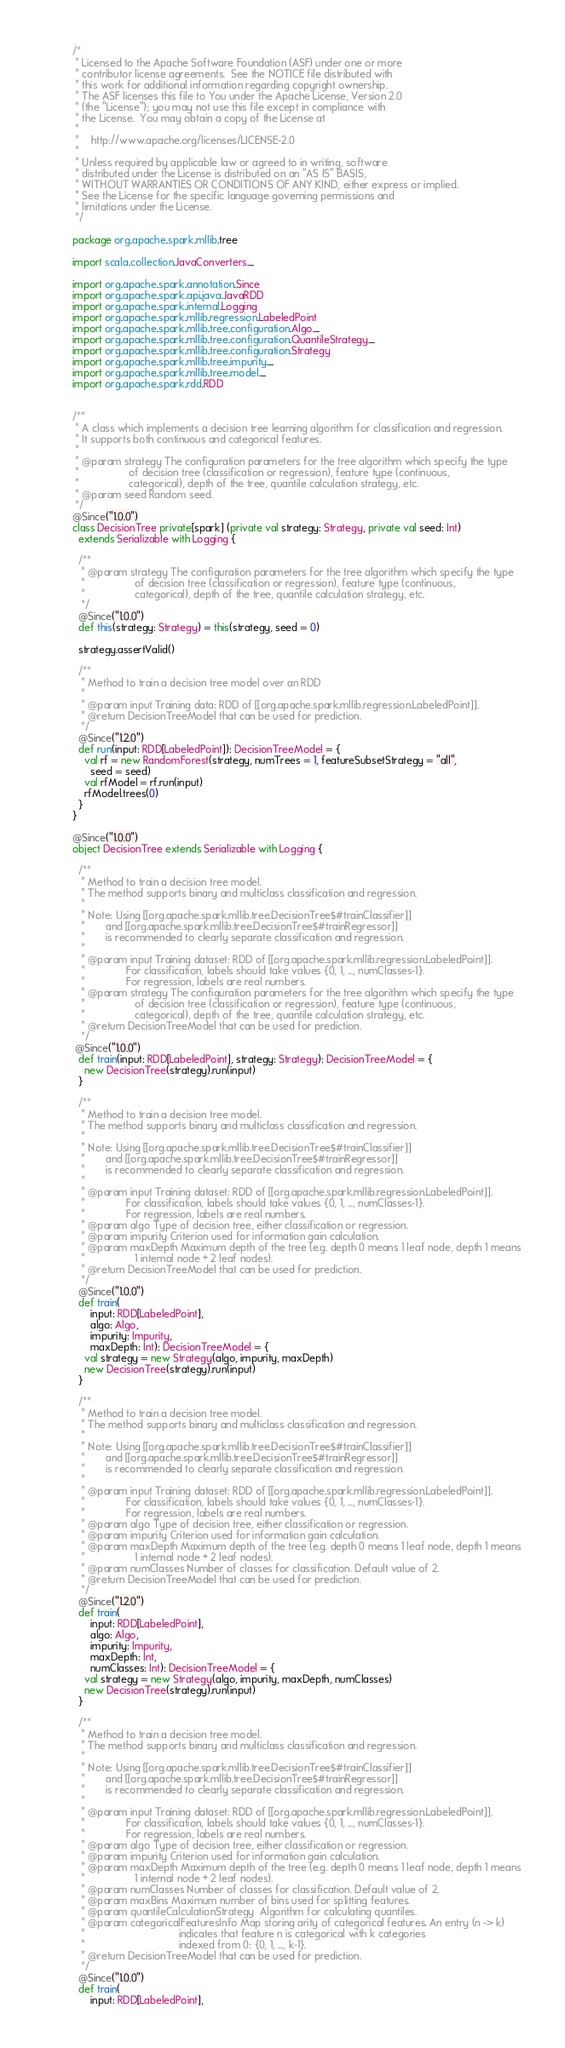Convert code to text. <code><loc_0><loc_0><loc_500><loc_500><_Scala_>/*
 * Licensed to the Apache Software Foundation (ASF) under one or more
 * contributor license agreements.  See the NOTICE file distributed with
 * this work for additional information regarding copyright ownership.
 * The ASF licenses this file to You under the Apache License, Version 2.0
 * (the "License"); you may not use this file except in compliance with
 * the License.  You may obtain a copy of the License at
 *
 *    http://www.apache.org/licenses/LICENSE-2.0
 *
 * Unless required by applicable law or agreed to in writing, software
 * distributed under the License is distributed on an "AS IS" BASIS,
 * WITHOUT WARRANTIES OR CONDITIONS OF ANY KIND, either express or implied.
 * See the License for the specific language governing permissions and
 * limitations under the License.
 */

package org.apache.spark.mllib.tree

import scala.collection.JavaConverters._

import org.apache.spark.annotation.Since
import org.apache.spark.api.java.JavaRDD
import org.apache.spark.internal.Logging
import org.apache.spark.mllib.regression.LabeledPoint
import org.apache.spark.mllib.tree.configuration.Algo._
import org.apache.spark.mllib.tree.configuration.QuantileStrategy._
import org.apache.spark.mllib.tree.configuration.Strategy
import org.apache.spark.mllib.tree.impurity._
import org.apache.spark.mllib.tree.model._
import org.apache.spark.rdd.RDD


/**
 * A class which implements a decision tree learning algorithm for classification and regression.
 * It supports both continuous and categorical features.
 *
 * @param strategy The configuration parameters for the tree algorithm which specify the type
 *                 of decision tree (classification or regression), feature type (continuous,
 *                 categorical), depth of the tree, quantile calculation strategy, etc.
 * @param seed Random seed.
 */
@Since("1.0.0")
class DecisionTree private[spark] (private val strategy: Strategy, private val seed: Int)
  extends Serializable with Logging {

  /**
   * @param strategy The configuration parameters for the tree algorithm which specify the type
   *                 of decision tree (classification or regression), feature type (continuous,
   *                 categorical), depth of the tree, quantile calculation strategy, etc.
   */
  @Since("1.0.0")
  def this(strategy: Strategy) = this(strategy, seed = 0)

  strategy.assertValid()

  /**
   * Method to train a decision tree model over an RDD
   *
   * @param input Training data: RDD of [[org.apache.spark.mllib.regression.LabeledPoint]].
   * @return DecisionTreeModel that can be used for prediction.
   */
  @Since("1.2.0")
  def run(input: RDD[LabeledPoint]): DecisionTreeModel = {
    val rf = new RandomForest(strategy, numTrees = 1, featureSubsetStrategy = "all",
      seed = seed)
    val rfModel = rf.run(input)
    rfModel.trees(0)
  }
}

@Since("1.0.0")
object DecisionTree extends Serializable with Logging {

  /**
   * Method to train a decision tree model.
   * The method supports binary and multiclass classification and regression.
   *
   * Note: Using [[org.apache.spark.mllib.tree.DecisionTree$#trainClassifier]]
   *       and [[org.apache.spark.mllib.tree.DecisionTree$#trainRegressor]]
   *       is recommended to clearly separate classification and regression.
   *
   * @param input Training dataset: RDD of [[org.apache.spark.mllib.regression.LabeledPoint]].
   *              For classification, labels should take values {0, 1, ..., numClasses-1}.
   *              For regression, labels are real numbers.
   * @param strategy The configuration parameters for the tree algorithm which specify the type
   *                 of decision tree (classification or regression), feature type (continuous,
   *                 categorical), depth of the tree, quantile calculation strategy, etc.
   * @return DecisionTreeModel that can be used for prediction.
   */
 @Since("1.0.0")
  def train(input: RDD[LabeledPoint], strategy: Strategy): DecisionTreeModel = {
    new DecisionTree(strategy).run(input)
  }

  /**
   * Method to train a decision tree model.
   * The method supports binary and multiclass classification and regression.
   *
   * Note: Using [[org.apache.spark.mllib.tree.DecisionTree$#trainClassifier]]
   *       and [[org.apache.spark.mllib.tree.DecisionTree$#trainRegressor]]
   *       is recommended to clearly separate classification and regression.
   *
   * @param input Training dataset: RDD of [[org.apache.spark.mllib.regression.LabeledPoint]].
   *              For classification, labels should take values {0, 1, ..., numClasses-1}.
   *              For regression, labels are real numbers.
   * @param algo Type of decision tree, either classification or regression.
   * @param impurity Criterion used for information gain calculation.
   * @param maxDepth Maximum depth of the tree (e.g. depth 0 means 1 leaf node, depth 1 means
   *                 1 internal node + 2 leaf nodes).
   * @return DecisionTreeModel that can be used for prediction.
   */
  @Since("1.0.0")
  def train(
      input: RDD[LabeledPoint],
      algo: Algo,
      impurity: Impurity,
      maxDepth: Int): DecisionTreeModel = {
    val strategy = new Strategy(algo, impurity, maxDepth)
    new DecisionTree(strategy).run(input)
  }

  /**
   * Method to train a decision tree model.
   * The method supports binary and multiclass classification and regression.
   *
   * Note: Using [[org.apache.spark.mllib.tree.DecisionTree$#trainClassifier]]
   *       and [[org.apache.spark.mllib.tree.DecisionTree$#trainRegressor]]
   *       is recommended to clearly separate classification and regression.
   *
   * @param input Training dataset: RDD of [[org.apache.spark.mllib.regression.LabeledPoint]].
   *              For classification, labels should take values {0, 1, ..., numClasses-1}.
   *              For regression, labels are real numbers.
   * @param algo Type of decision tree, either classification or regression.
   * @param impurity Criterion used for information gain calculation.
   * @param maxDepth Maximum depth of the tree (e.g. depth 0 means 1 leaf node, depth 1 means
   *                 1 internal node + 2 leaf nodes).
   * @param numClasses Number of classes for classification. Default value of 2.
   * @return DecisionTreeModel that can be used for prediction.
   */
  @Since("1.2.0")
  def train(
      input: RDD[LabeledPoint],
      algo: Algo,
      impurity: Impurity,
      maxDepth: Int,
      numClasses: Int): DecisionTreeModel = {
    val strategy = new Strategy(algo, impurity, maxDepth, numClasses)
    new DecisionTree(strategy).run(input)
  }

  /**
   * Method to train a decision tree model.
   * The method supports binary and multiclass classification and regression.
   *
   * Note: Using [[org.apache.spark.mllib.tree.DecisionTree$#trainClassifier]]
   *       and [[org.apache.spark.mllib.tree.DecisionTree$#trainRegressor]]
   *       is recommended to clearly separate classification and regression.
   *
   * @param input Training dataset: RDD of [[org.apache.spark.mllib.regression.LabeledPoint]].
   *              For classification, labels should take values {0, 1, ..., numClasses-1}.
   *              For regression, labels are real numbers.
   * @param algo Type of decision tree, either classification or regression.
   * @param impurity Criterion used for information gain calculation.
   * @param maxDepth Maximum depth of the tree (e.g. depth 0 means 1 leaf node, depth 1 means
   *                 1 internal node + 2 leaf nodes).
   * @param numClasses Number of classes for classification. Default value of 2.
   * @param maxBins Maximum number of bins used for splitting features.
   * @param quantileCalculationStrategy  Algorithm for calculating quantiles.
   * @param categoricalFeaturesInfo Map storing arity of categorical features. An entry (n -> k)
   *                                indicates that feature n is categorical with k categories
   *                                indexed from 0: {0, 1, ..., k-1}.
   * @return DecisionTreeModel that can be used for prediction.
   */
  @Since("1.0.0")
  def train(
      input: RDD[LabeledPoint],</code> 